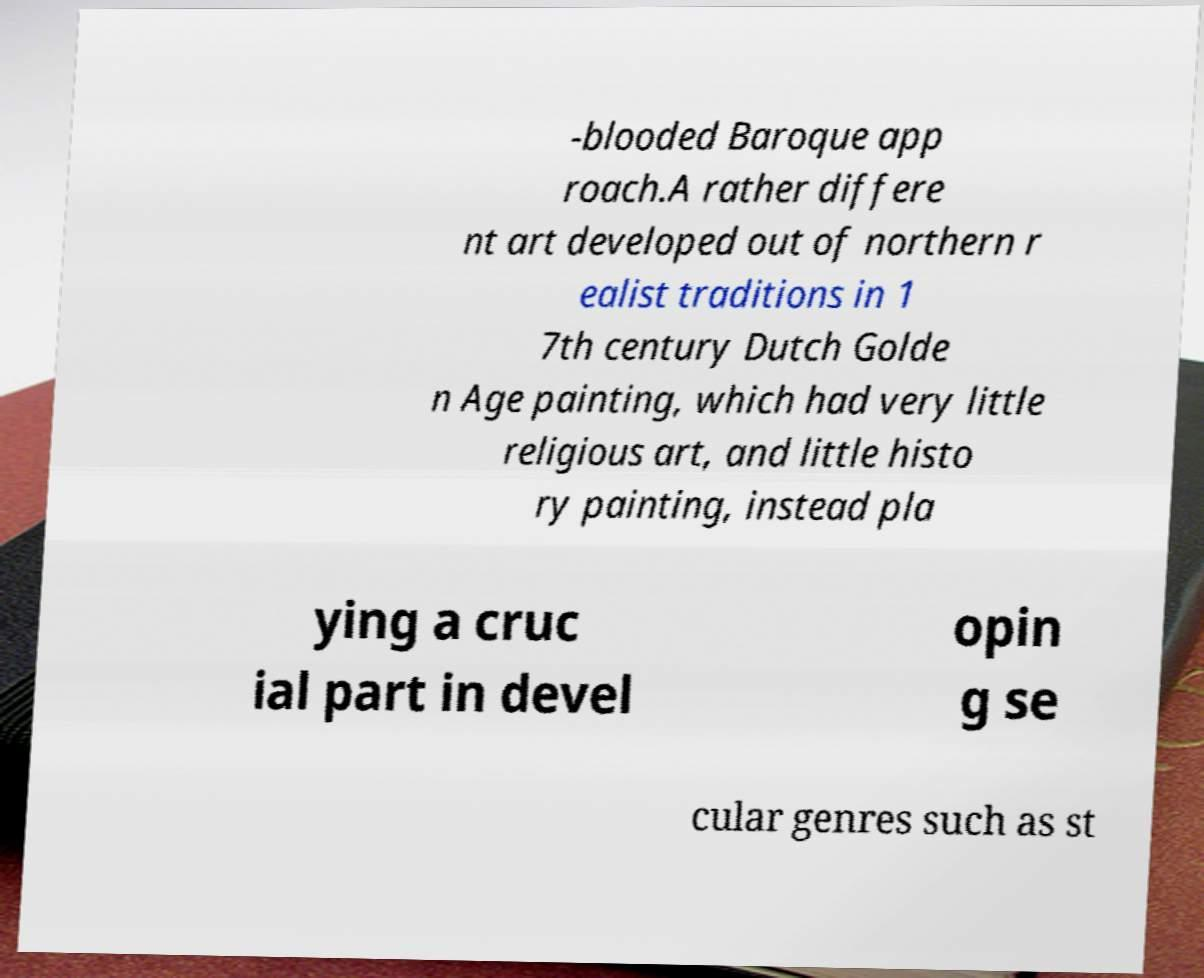There's text embedded in this image that I need extracted. Can you transcribe it verbatim? -blooded Baroque app roach.A rather differe nt art developed out of northern r ealist traditions in 1 7th century Dutch Golde n Age painting, which had very little religious art, and little histo ry painting, instead pla ying a cruc ial part in devel opin g se cular genres such as st 